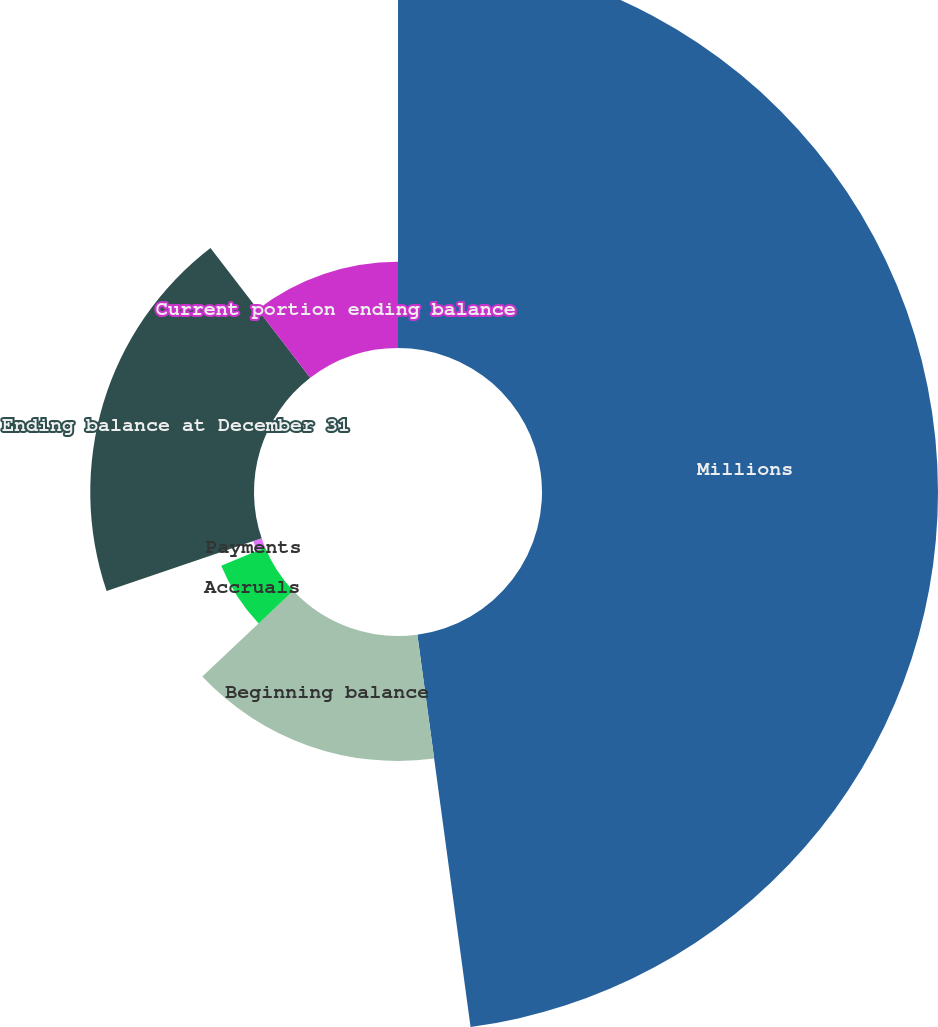Convert chart to OTSL. <chart><loc_0><loc_0><loc_500><loc_500><pie_chart><fcel>Millions<fcel>Beginning balance<fcel>Accruals<fcel>Payments<fcel>Ending balance at December 31<fcel>Current portion ending balance<nl><fcel>47.86%<fcel>15.11%<fcel>5.75%<fcel>1.07%<fcel>19.79%<fcel>10.43%<nl></chart> 